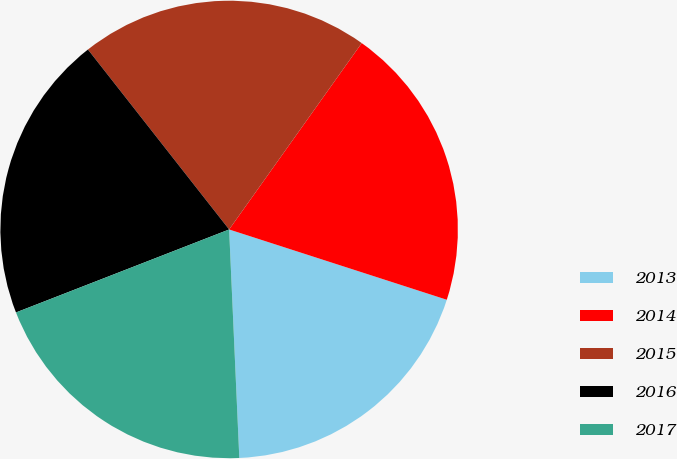<chart> <loc_0><loc_0><loc_500><loc_500><pie_chart><fcel>2013<fcel>2014<fcel>2015<fcel>2016<fcel>2017<nl><fcel>19.32%<fcel>20.13%<fcel>20.43%<fcel>20.32%<fcel>19.8%<nl></chart> 